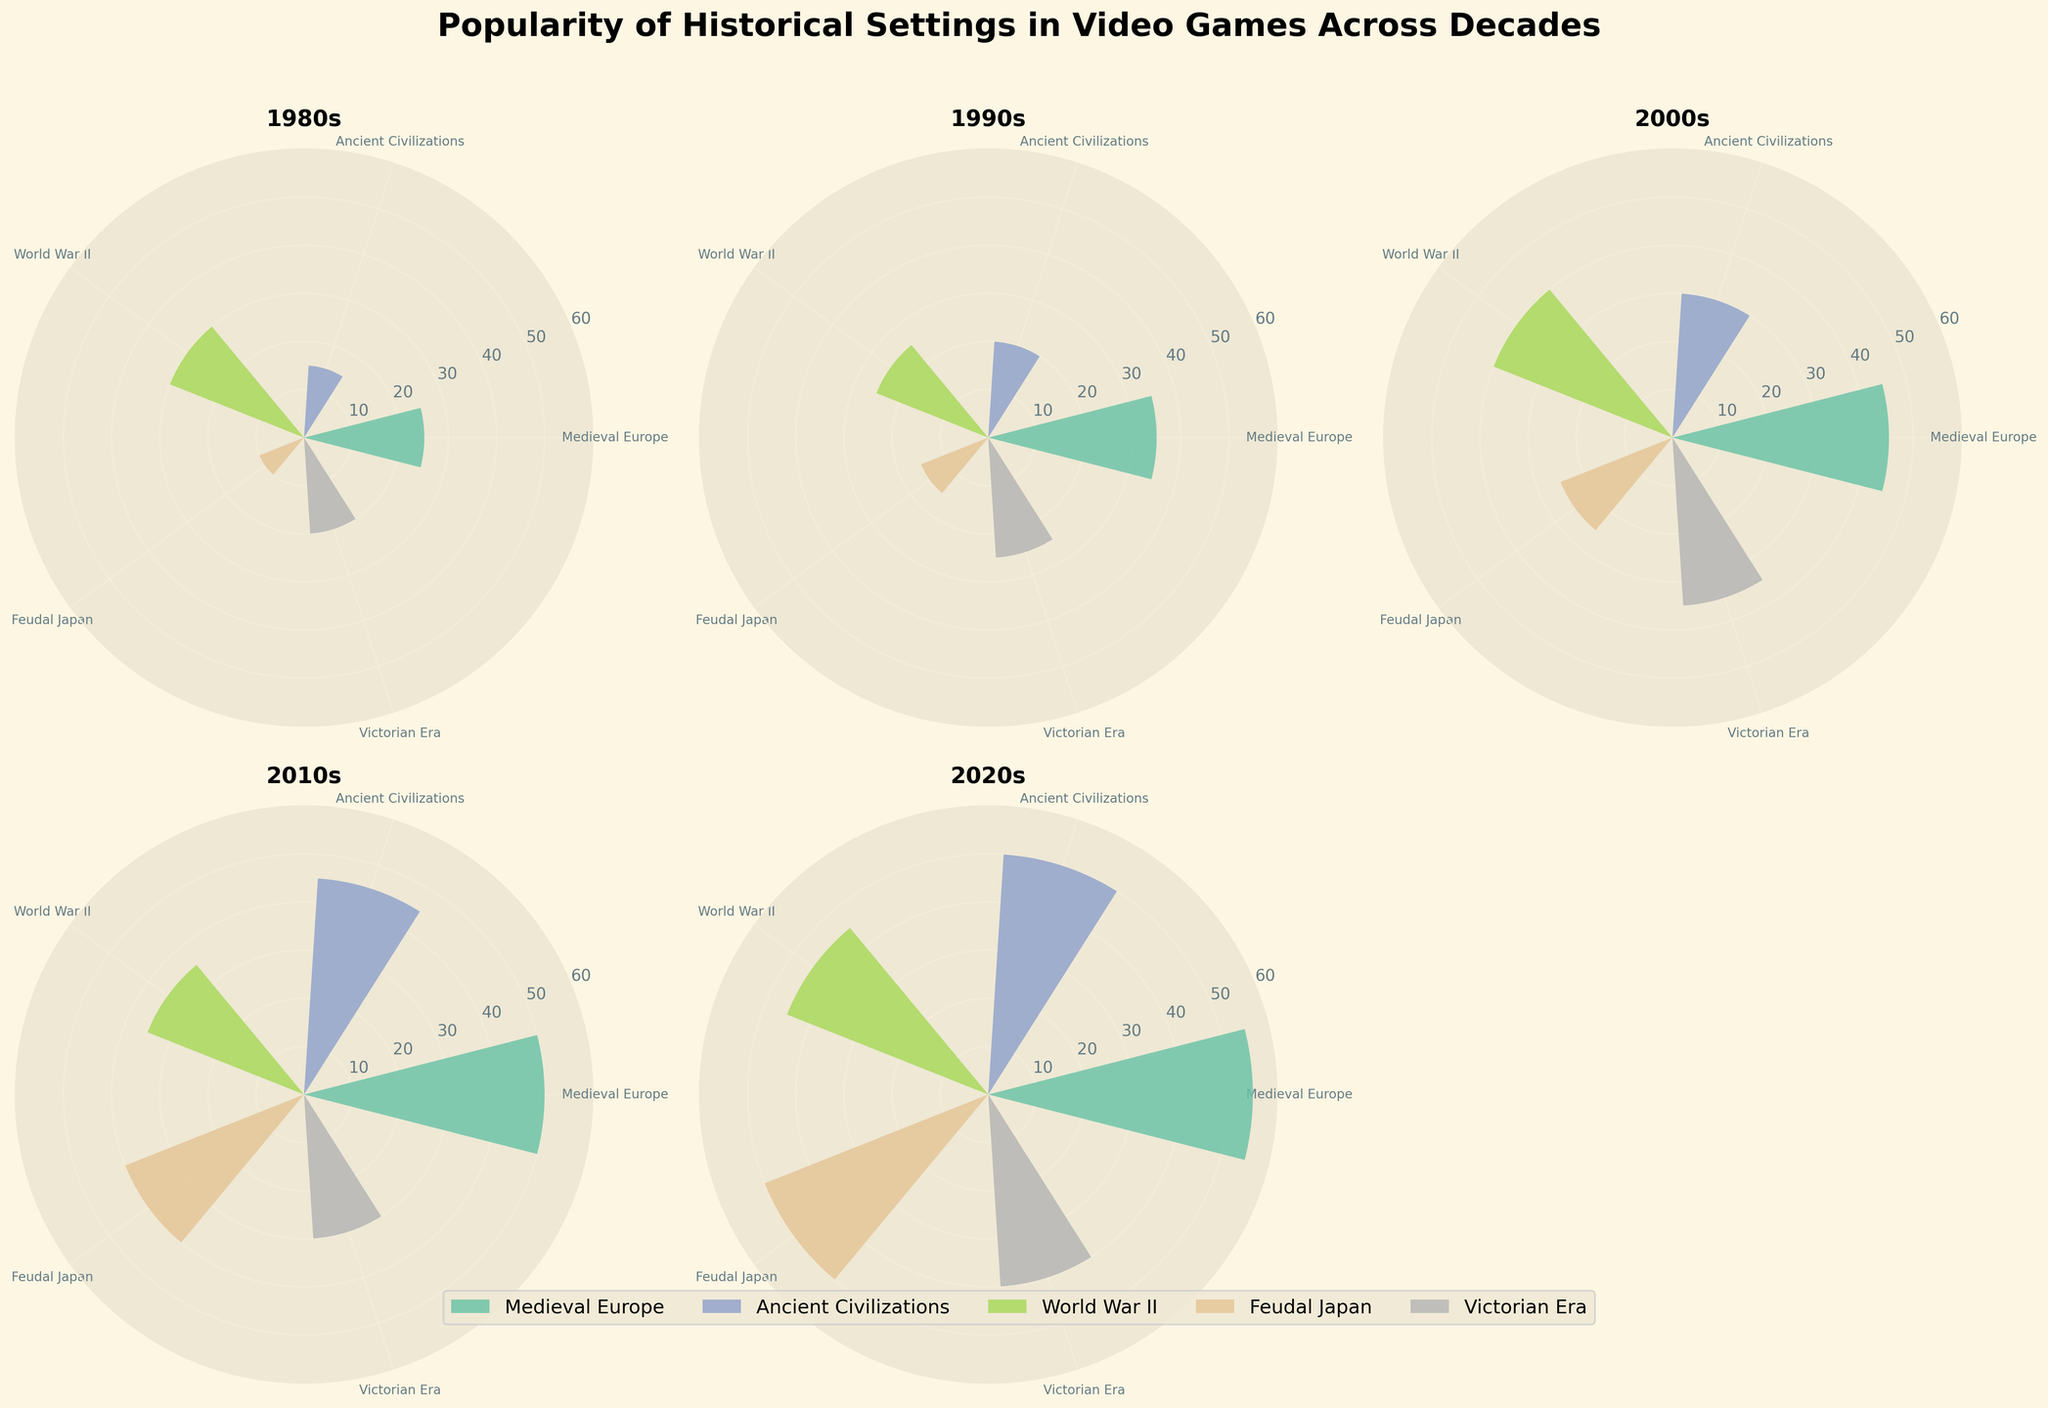What is the most popular historical setting in the 1980s? To find the most popular historical setting in the 1980s, look at the subplot labeled "1980s" and find the theme with the tallest bar. "World War II" has the tallest bar with a value of 30.
Answer: World War II Which theme gained the most popularity between the 1990s and the 2000s? To find this, compare the values for each theme between the 1990s and 2000s subplots. "Medieval Europe" increased from 35 in the 1990s to 45 in the 2000s, which is a 10-point increase. Other themes increased less or had smaller differences.
Answer: Medieval Europe How does the popularity of "Ancient Civilizations" in the 2010s compare to the 2020s? Look at the bars representing "Ancient Civilizations" in the subplots of the 2010s and the 2020s. In the 2010s the value is 45, and in the 2020s the value is 50. The popularity increased by 5 points.
Answer: The popularity increased What is the average popularity of "Feudal Japan" across all decades? Sum the popularity values of "Feudal Japan" from all decades (10 for 1980s, 15 for 1990s, 25 for 2000s, 40 for 2010s, and 50 for 2020s) and then divide by the number of decades (5). The calculation is (10 + 15 + 25 + 40 + 50) / 5 = 28.
Answer: 28 Which decade has the lowest popularity for "Victorian Era"? Look at all the subplots and find the decade where the bar for "Victorian Era" is the shortest. In the 2010s, "Victorian Era" has a value of 30, which is the lowest among all decades.
Answer: 2010s Between "World War II" and "Medieval Europe," which theme was more popular in the 2020s? Refer to the subplot for the 2020s and compare the bars for "World War II" and "Medieval Europe." "Medieval Europe" has a value of 55, while "World War II" has a value of 45.
Answer: Medieval Europe Which historical setting showed the most significant increase in popularity from the 1980s to the 2020s? For each historical setting, subtract the 1980s value from the 2020s value. The differences are: 
- Medieval Europe: 55 - 25 = 30
- Ancient Civilizations: 50 - 15 = 35
- World War II: 45 - 30 = 15
- Feudal Japan: 50 - 10 = 40
- Victorian Era: 40 - 20 = 20
"Feudal Japan" has the highest increase with 40 points.
Answer: Feudal Japan 